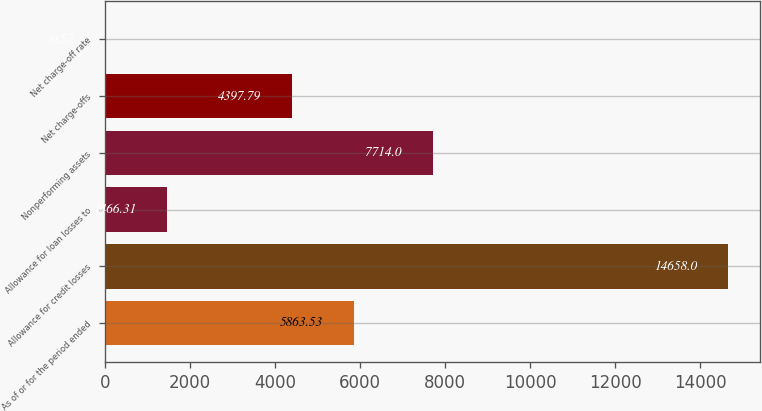Convert chart. <chart><loc_0><loc_0><loc_500><loc_500><bar_chart><fcel>As of or for the period ended<fcel>Allowance for credit losses<fcel>Allowance for loan losses to<fcel>Nonperforming assets<fcel>Net charge-offs<fcel>Net charge-off rate<nl><fcel>5863.53<fcel>14658<fcel>1466.31<fcel>7714<fcel>4397.79<fcel>0.57<nl></chart> 